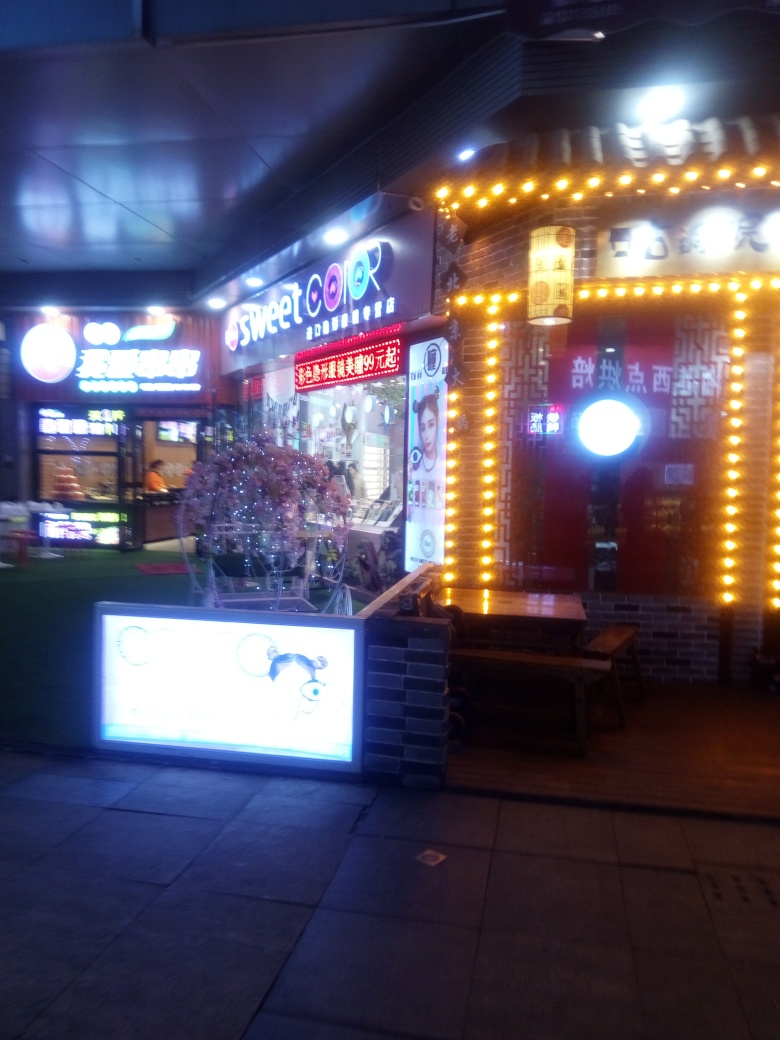What do you think is the cultural relevance of this image? This image portrays a glimpse of urban nightlife culture, emphasizing the importance of visual appeal and aesthetics in attracting customers. The colorful, lit-up façade reflects a modern consumer culture that focuses heavily on style and personal appearance. 